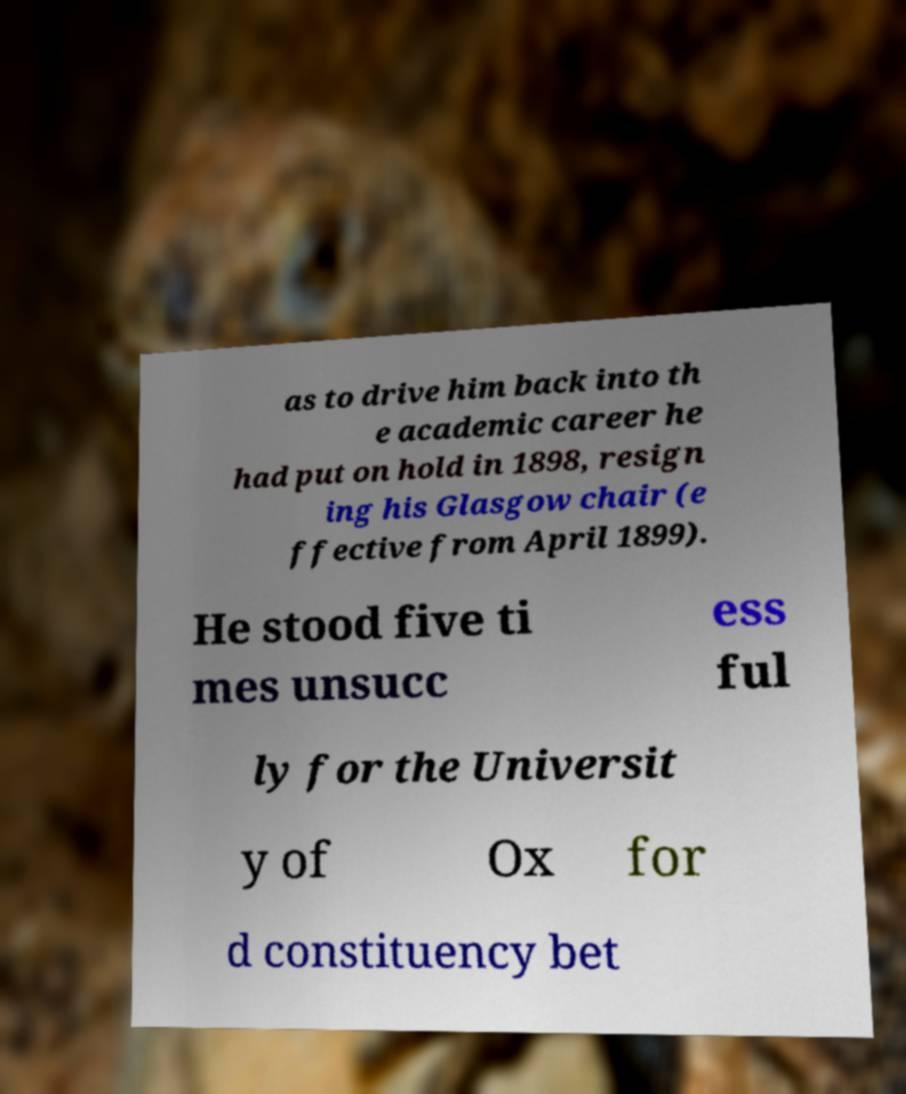Could you extract and type out the text from this image? as to drive him back into th e academic career he had put on hold in 1898, resign ing his Glasgow chair (e ffective from April 1899). He stood five ti mes unsucc ess ful ly for the Universit y of Ox for d constituency bet 